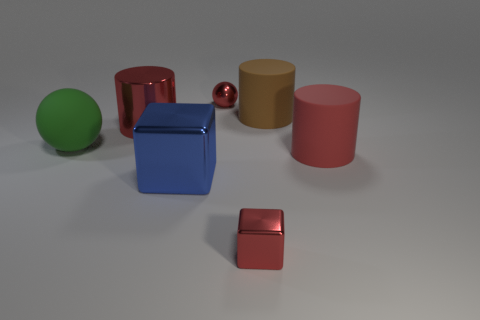What number of other things are there of the same color as the rubber sphere?
Ensure brevity in your answer.  0. There is another cylinder that is the same color as the metal cylinder; what material is it?
Keep it short and to the point. Rubber. Are there fewer brown cylinders than cylinders?
Your answer should be very brief. Yes. Does the big metallic object behind the big red rubber cylinder have the same color as the small metal sphere?
Your answer should be compact. Yes. What color is the large cylinder that is made of the same material as the big brown object?
Your answer should be compact. Red. Is the size of the blue block the same as the brown rubber object?
Make the answer very short. Yes. What is the large blue thing made of?
Your answer should be very brief. Metal. There is a blue object that is the same size as the red rubber cylinder; what is its material?
Your answer should be very brief. Metal. Is there a red thing that has the same size as the green thing?
Your answer should be compact. Yes. Are there the same number of big brown rubber cylinders in front of the big green matte ball and blue cubes that are right of the tiny red shiny ball?
Give a very brief answer. Yes. 